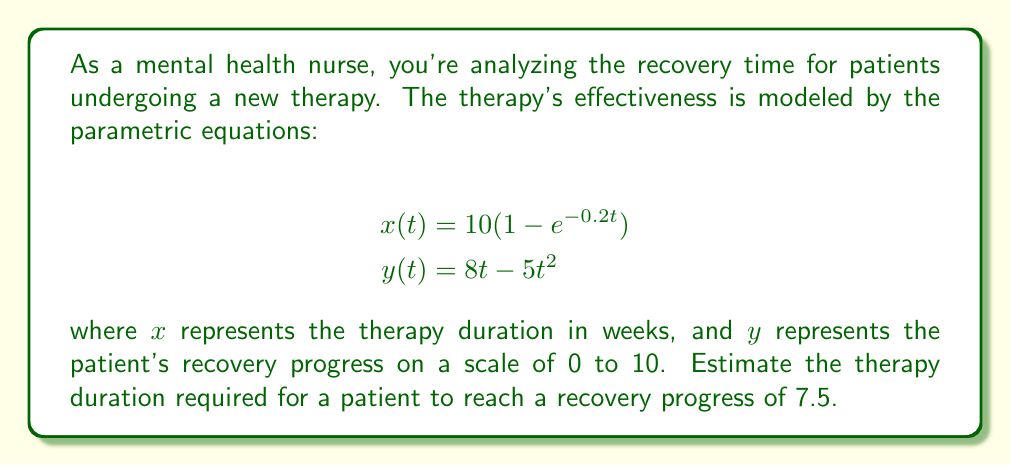Show me your answer to this math problem. To solve this problem, we need to follow these steps:

1) We're looking for the point where $y = 7.5$. We need to find the corresponding $t$ value, then use that to calculate $x$.

2) From the equation for $y(t)$:

   $$7.5 = 8t - 5t^2$$

3) Rearrange this into standard quadratic form:

   $$5t^2 - 8t + 7.5 = 0$$

4) We can solve this using the quadratic formula: $t = \frac{-b \pm \sqrt{b^2 - 4ac}}{2a}$

   Where $a = 5$, $b = -8$, and $c = 7.5$

5) Plugging in these values:

   $$t = \frac{8 \pm \sqrt{64 - 150}}{10} = \frac{8 \pm \sqrt{-86}}{10}$$

6) Since we can't have a negative value under the square root in real numbers, we need to consider the maximum value of $y(t)$.

7) To find the maximum, we differentiate $y$ with respect to $t$ and set it to zero:

   $$\frac{dy}{dt} = 8 - 10t = 0$$
   $$t = 0.8$$

8) The maximum value of $y$ occurs at $t = 0.8$:

   $$y(0.8) = 8(0.8) - 5(0.8)^2 = 6.4 - 3.2 = 3.2$$

9) This means the maximum recovery progress is 3.2, which is less than our target of 7.5.

10) Therefore, the patient cannot reach a recovery progress of 7.5 with this therapy model.

11) We can, however, estimate the therapy duration for the maximum recovery progress:

    $$x(0.8) = 10(1 - e^{-0.2(0.8)}) \approx 1.48$$

Therefore, the maximum recovery progress of 3.2 is reached after approximately 1.48 weeks of therapy.
Answer: The patient cannot reach a recovery progress of 7.5 with this therapy model. The maximum achievable recovery progress is approximately 3.2, which occurs after about 1.48 weeks of therapy. 